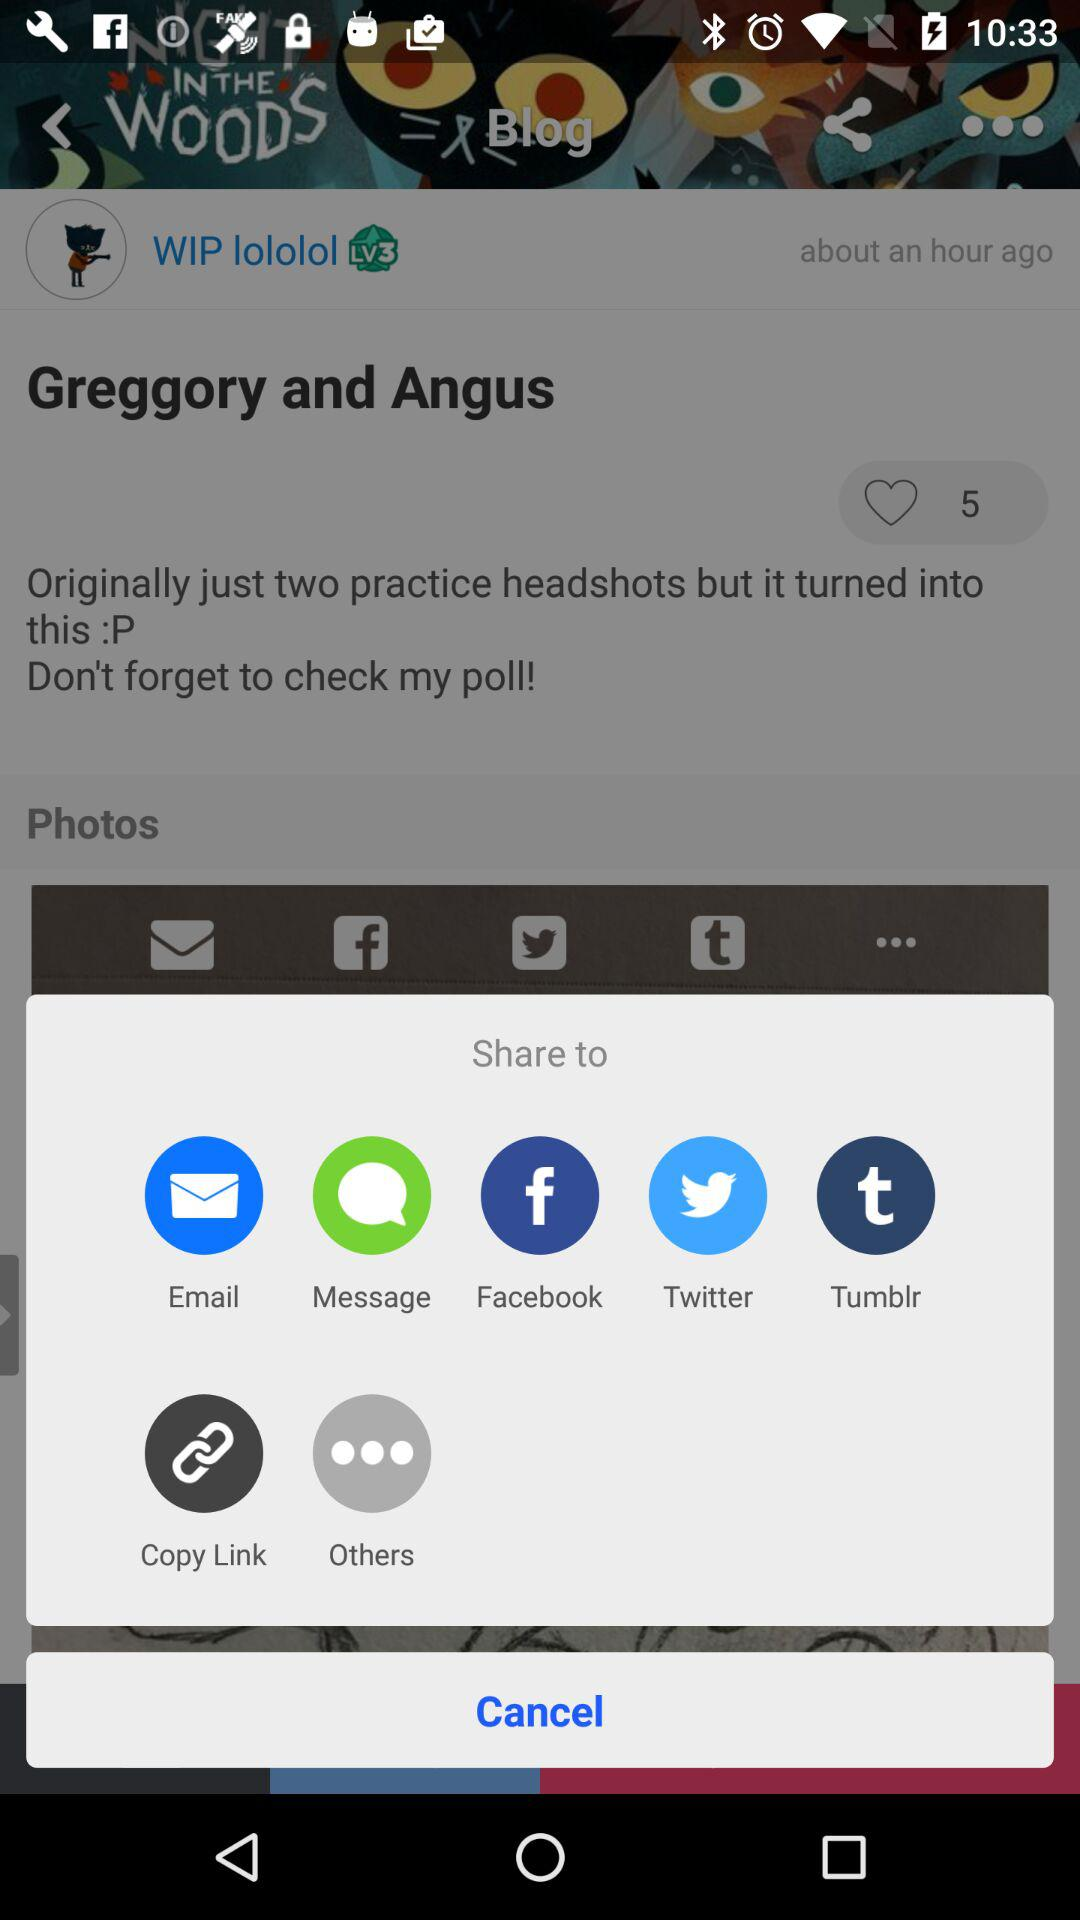What are the different applications through which we can share? You can share with "Email", "Message", "Facebook", "Twitter", "Tumblr", "Copy Link" and "Others". 